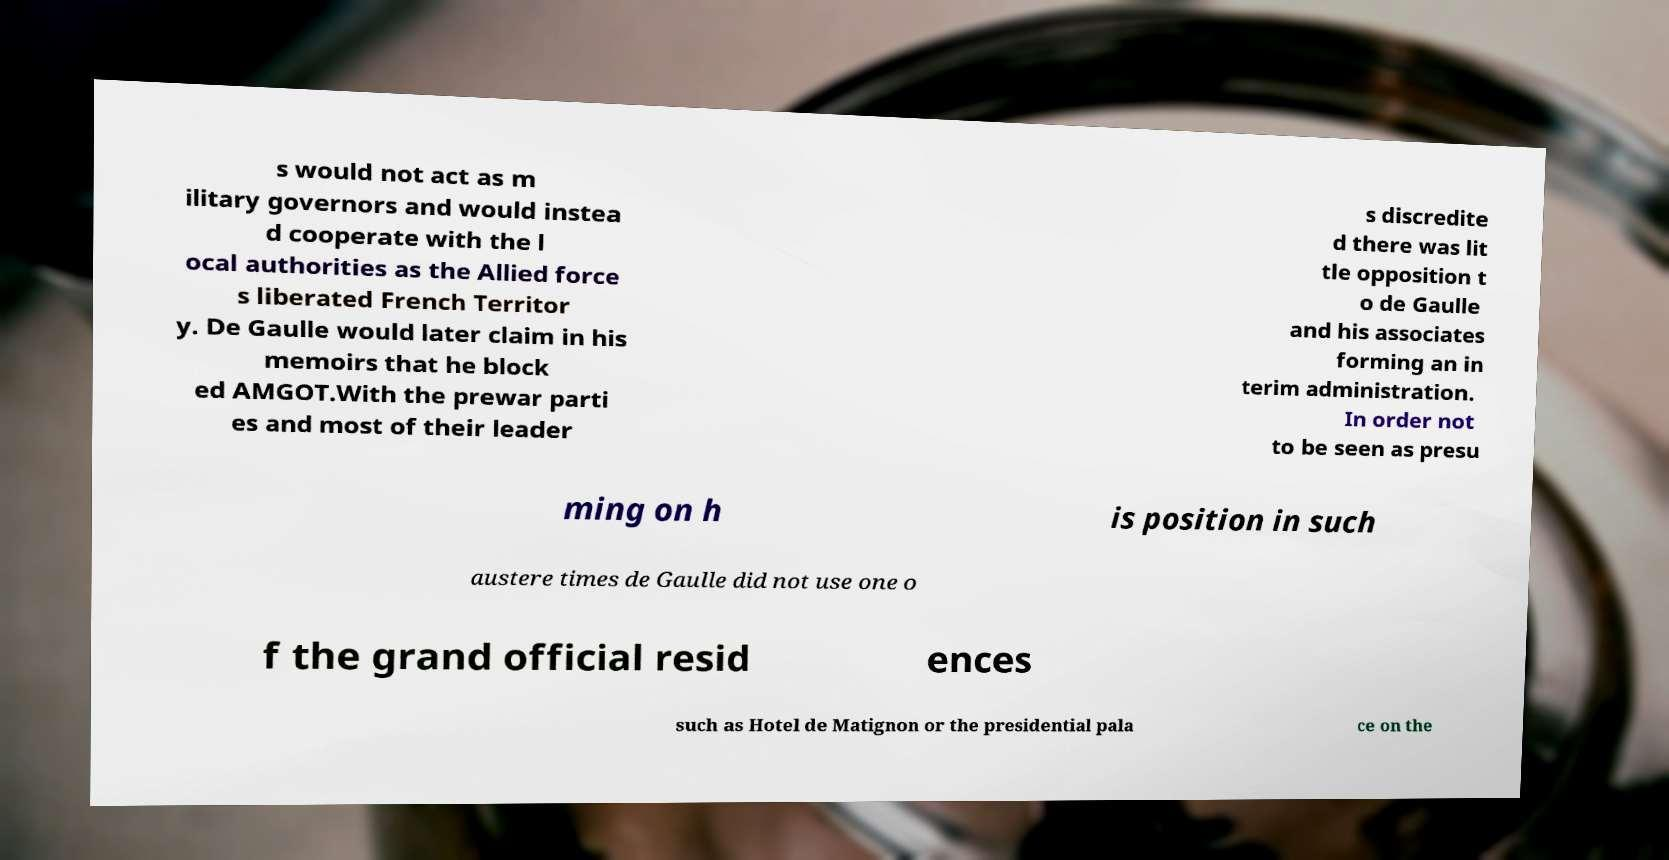Can you accurately transcribe the text from the provided image for me? s would not act as m ilitary governors and would instea d cooperate with the l ocal authorities as the Allied force s liberated French Territor y. De Gaulle would later claim in his memoirs that he block ed AMGOT.With the prewar parti es and most of their leader s discredite d there was lit tle opposition t o de Gaulle and his associates forming an in terim administration. In order not to be seen as presu ming on h is position in such austere times de Gaulle did not use one o f the grand official resid ences such as Hotel de Matignon or the presidential pala ce on the 